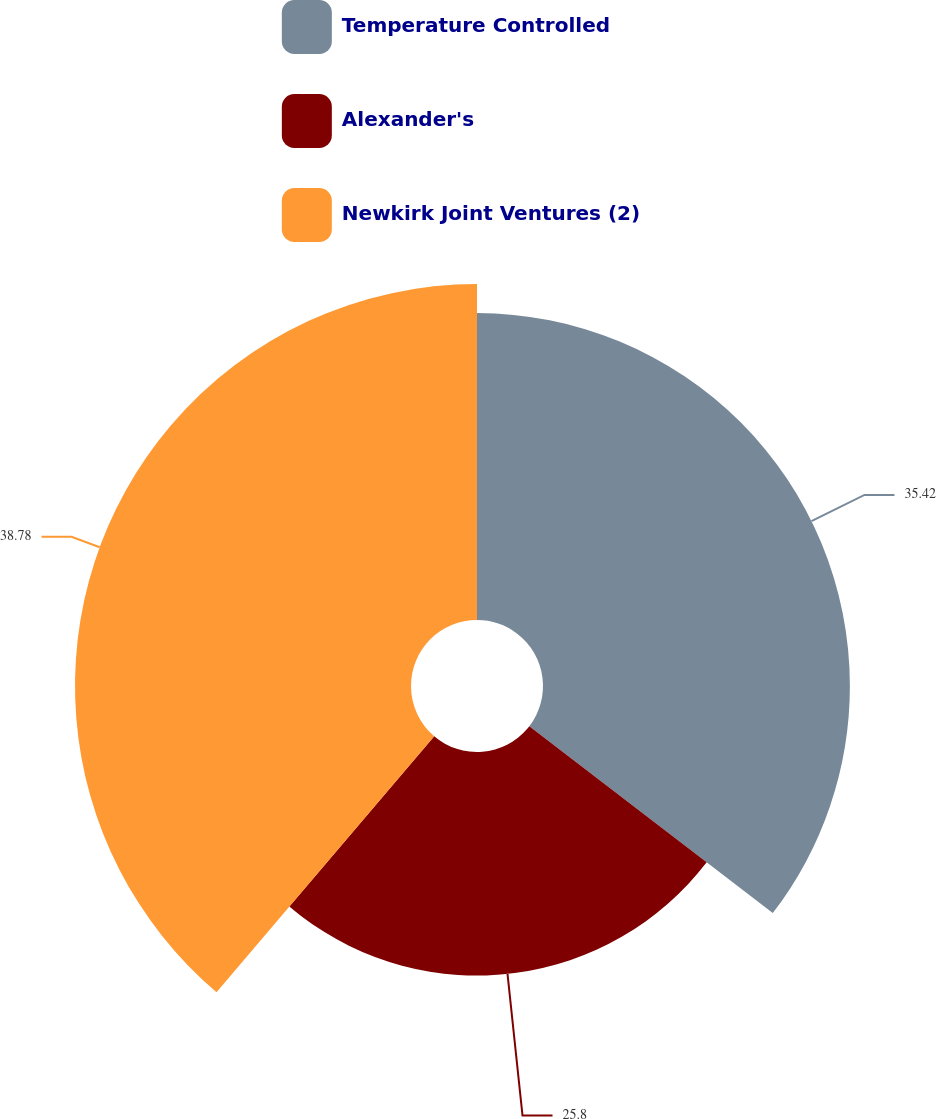Convert chart. <chart><loc_0><loc_0><loc_500><loc_500><pie_chart><fcel>Temperature Controlled<fcel>Alexander's<fcel>Newkirk Joint Ventures (2)<nl><fcel>35.42%<fcel>25.8%<fcel>38.78%<nl></chart> 